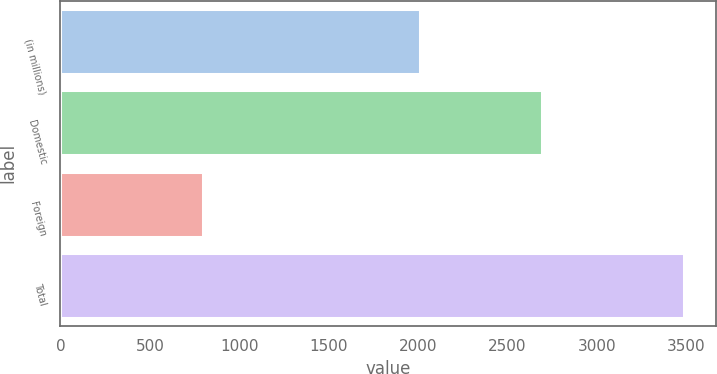Convert chart to OTSL. <chart><loc_0><loc_0><loc_500><loc_500><bar_chart><fcel>(in millions)<fcel>Domestic<fcel>Foreign<fcel>Total<nl><fcel>2012<fcel>2690<fcel>798<fcel>3488<nl></chart> 